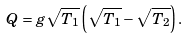Convert formula to latex. <formula><loc_0><loc_0><loc_500><loc_500>Q = g \sqrt { T _ { 1 } } \left ( \sqrt { T _ { 1 } } - \sqrt { T _ { 2 } } \right ) .</formula> 